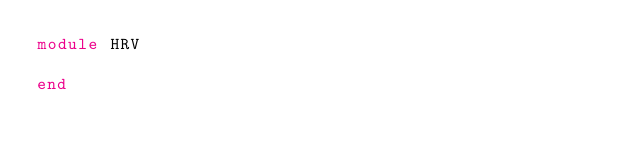<code> <loc_0><loc_0><loc_500><loc_500><_Julia_>module HRV
    
end</code> 